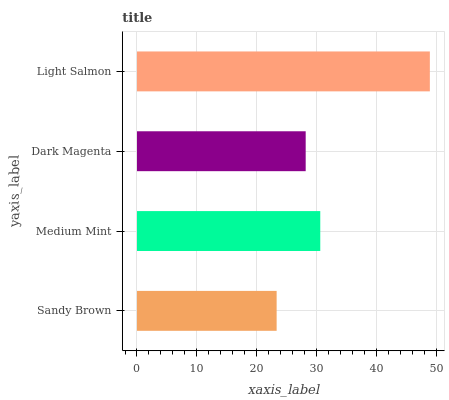Is Sandy Brown the minimum?
Answer yes or no. Yes. Is Light Salmon the maximum?
Answer yes or no. Yes. Is Medium Mint the minimum?
Answer yes or no. No. Is Medium Mint the maximum?
Answer yes or no. No. Is Medium Mint greater than Sandy Brown?
Answer yes or no. Yes. Is Sandy Brown less than Medium Mint?
Answer yes or no. Yes. Is Sandy Brown greater than Medium Mint?
Answer yes or no. No. Is Medium Mint less than Sandy Brown?
Answer yes or no. No. Is Medium Mint the high median?
Answer yes or no. Yes. Is Dark Magenta the low median?
Answer yes or no. Yes. Is Sandy Brown the high median?
Answer yes or no. No. Is Medium Mint the low median?
Answer yes or no. No. 